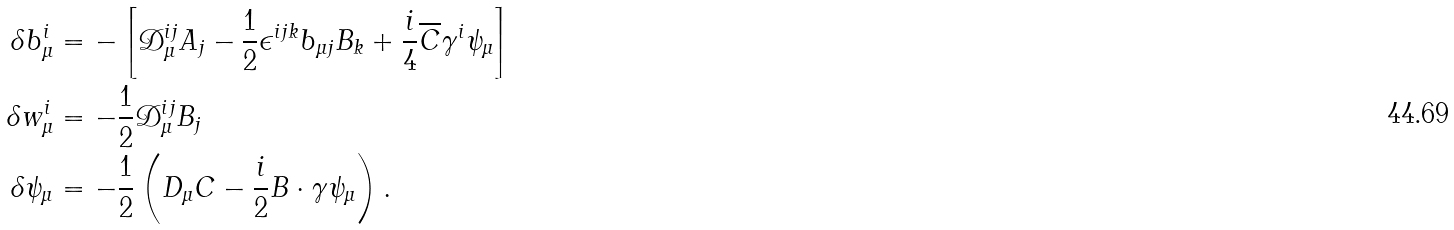Convert formula to latex. <formula><loc_0><loc_0><loc_500><loc_500>\delta b _ { \mu } ^ { i } & = - \left [ \mathcal { D } _ { \mu } ^ { i j } A _ { j } - \frac { 1 } { 2 } \epsilon ^ { i j k } b _ { \mu j } B _ { k } + \frac { i } { 4 } \overline { C } \gamma ^ { i } \psi _ { \mu } \right ] \\ \delta w _ { \mu } ^ { i } & = - \frac { 1 } { 2 } \mathcal { D } _ { \mu } ^ { i j } B _ { j } \\ \delta \psi _ { \mu } & = - \frac { 1 } { 2 } \left ( D _ { \mu } C - \frac { i } { 2 } B \cdot \gamma \psi _ { \mu } \right ) .</formula> 